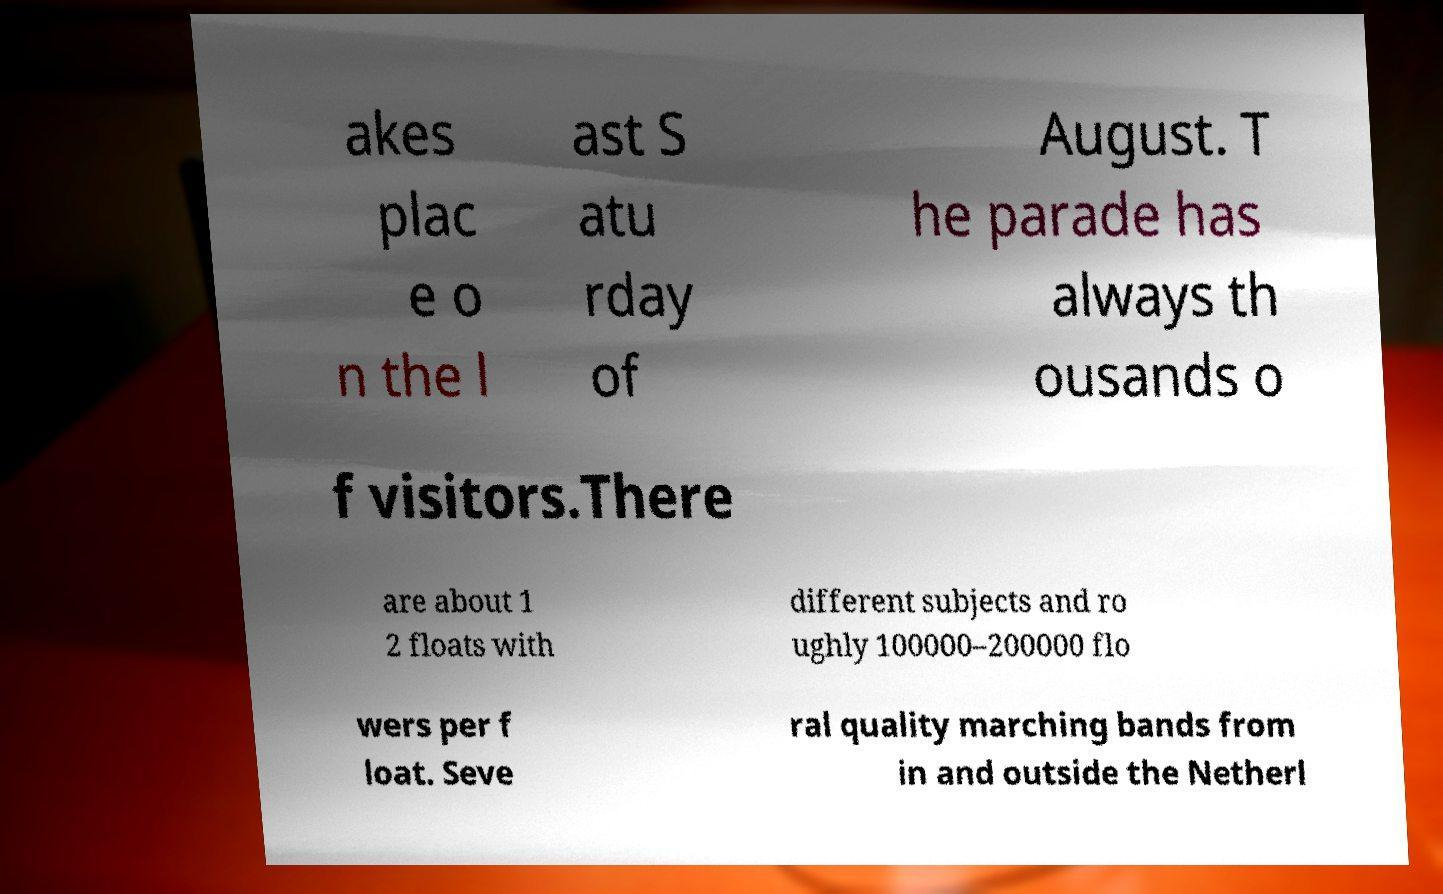Please read and relay the text visible in this image. What does it say? akes plac e o n the l ast S atu rday of August. T he parade has always th ousands o f visitors.There are about 1 2 floats with different subjects and ro ughly 100000–200000 flo wers per f loat. Seve ral quality marching bands from in and outside the Netherl 